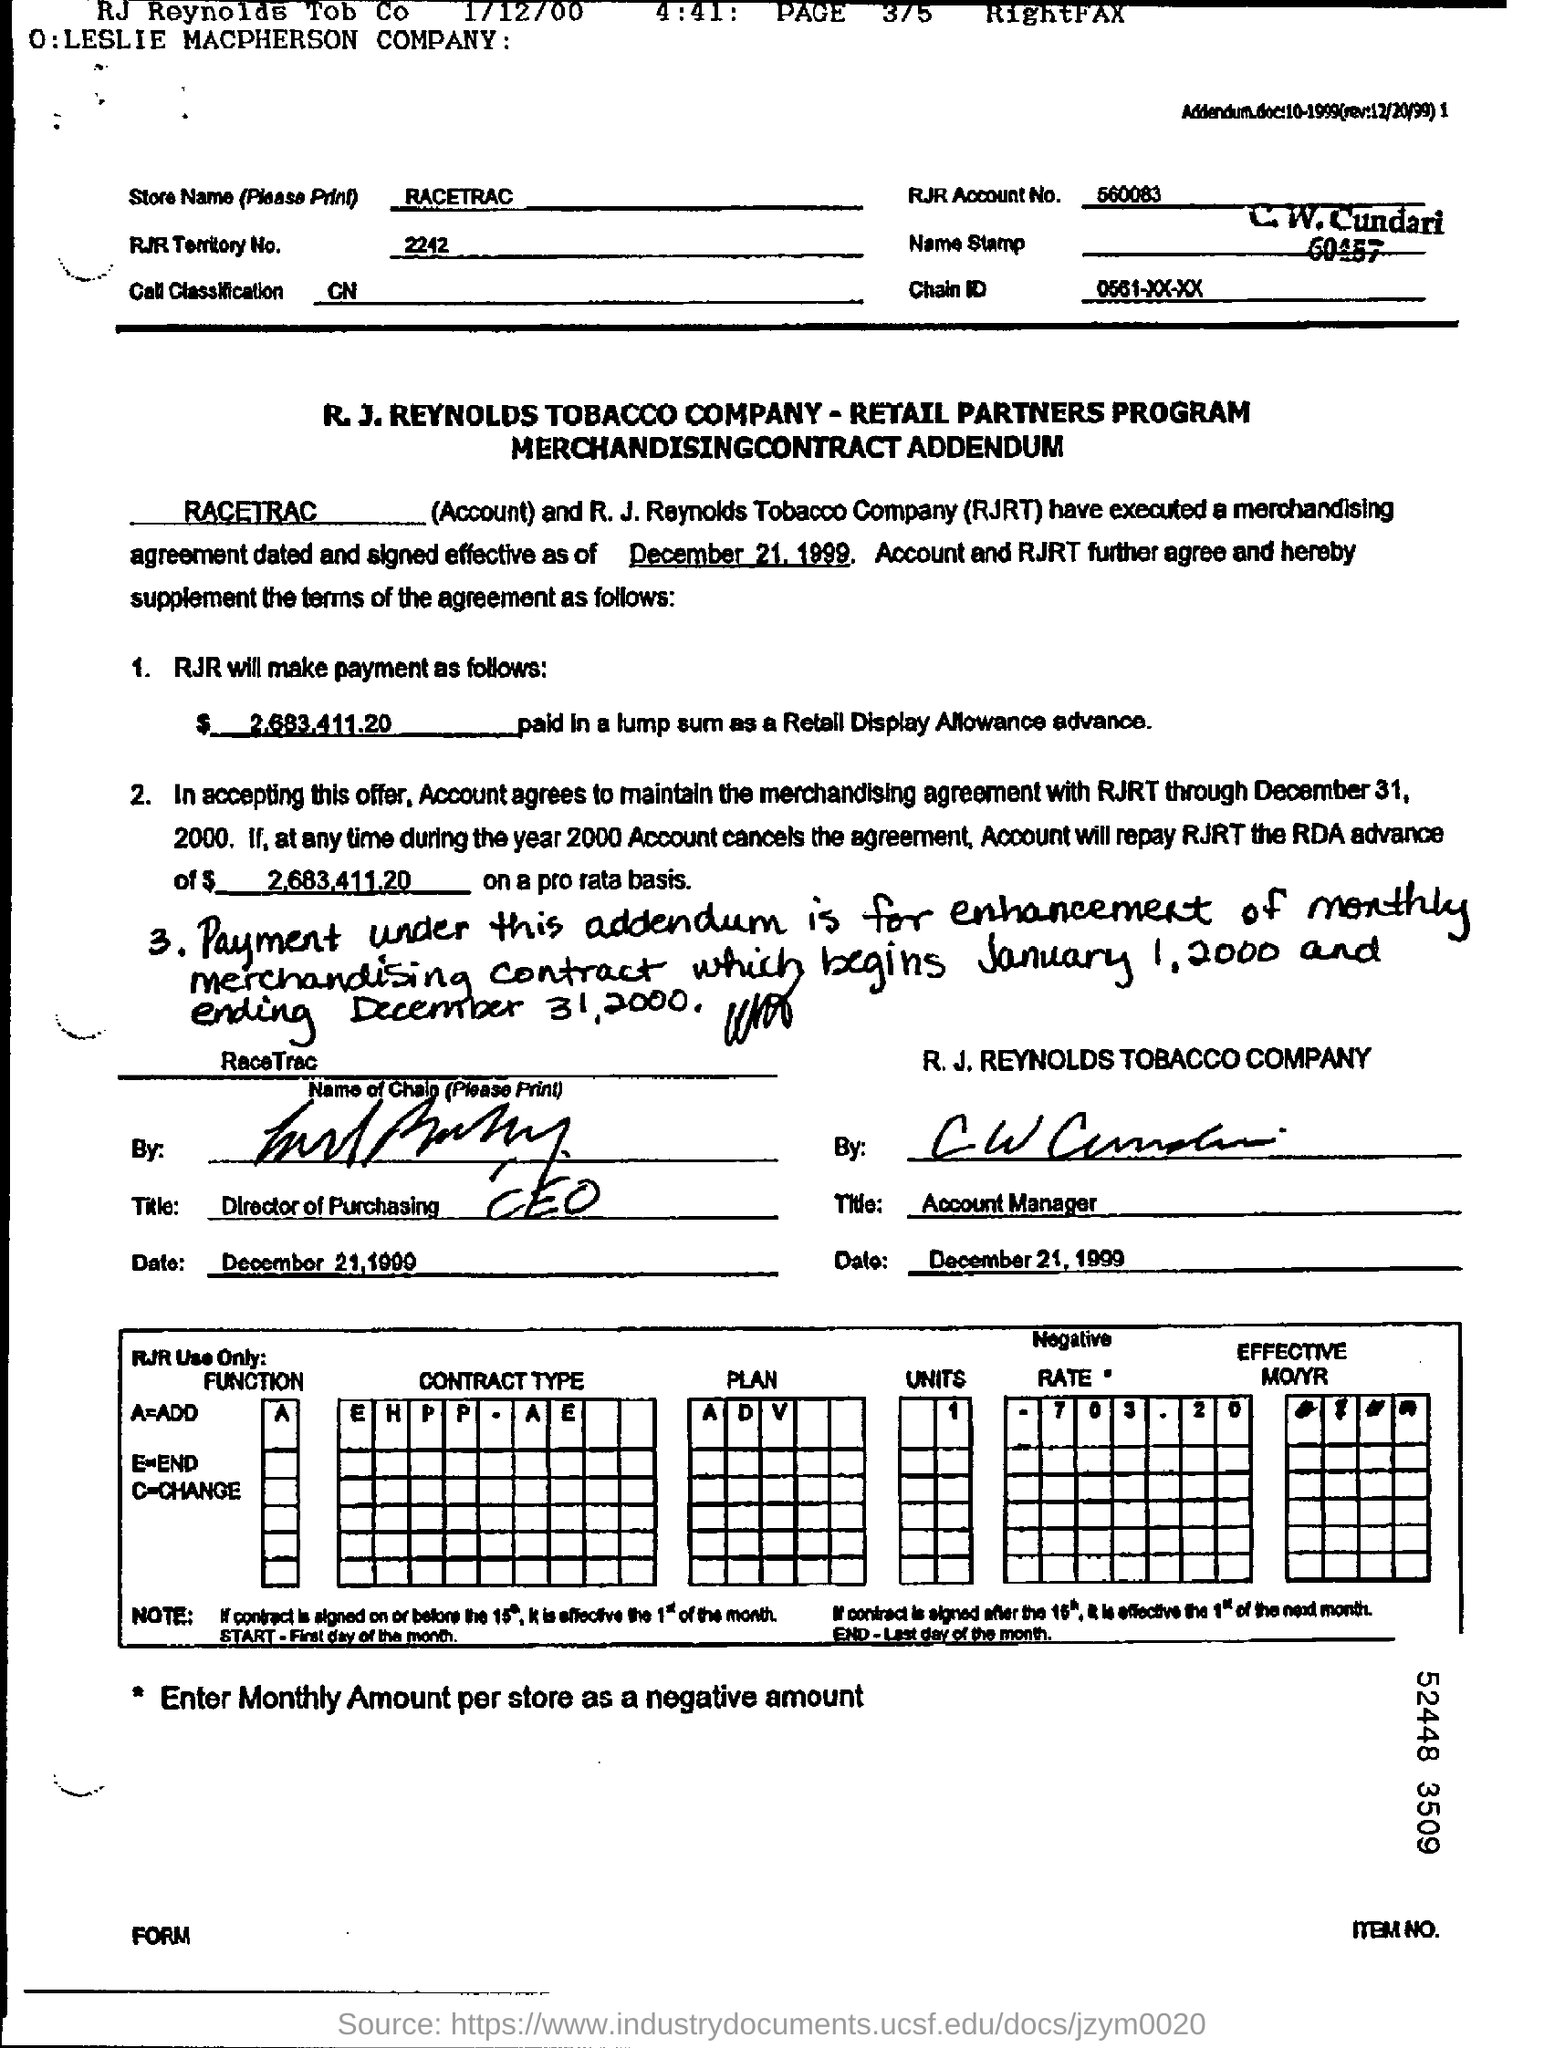What is the RJR Account no.?
Keep it short and to the point. 560083. What is the store name?
Offer a terse response. RACETRAC. What is RJR TERRITORY No.?
Ensure brevity in your answer.  2242. 